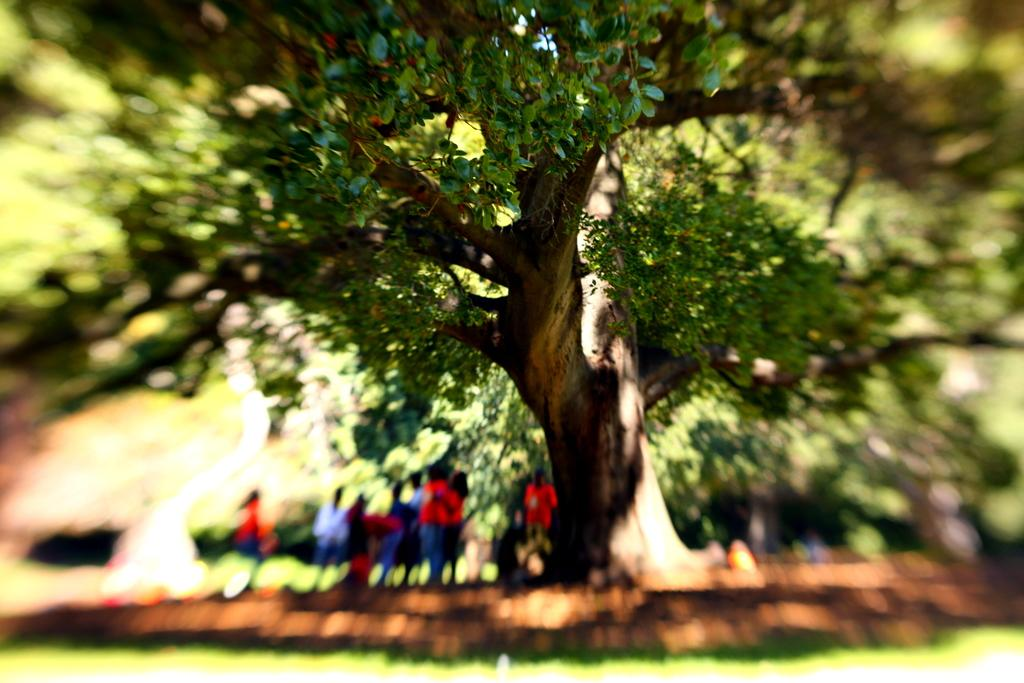What type of vegetation can be seen in the image? There are trees in the image. Are there any human figures present in the image? Yes, there are people in the image. What is the ground surface like in the image? There is grass in the image. Is there any part of the image that is not clear? Yes, a part of the image is blurred. What type of yarn is being used by the people in the image? There is no yarn present in the image. What is on the plate that the people are holding in the image? There is no plate present in the image. 